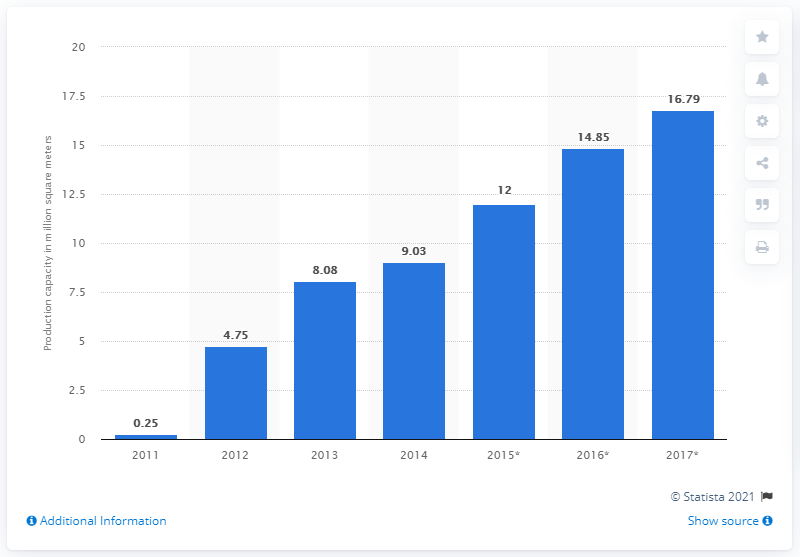Mention a couple of crucial points in this snapshot. In 2014, the production capacity of CSOT was 9.03... 